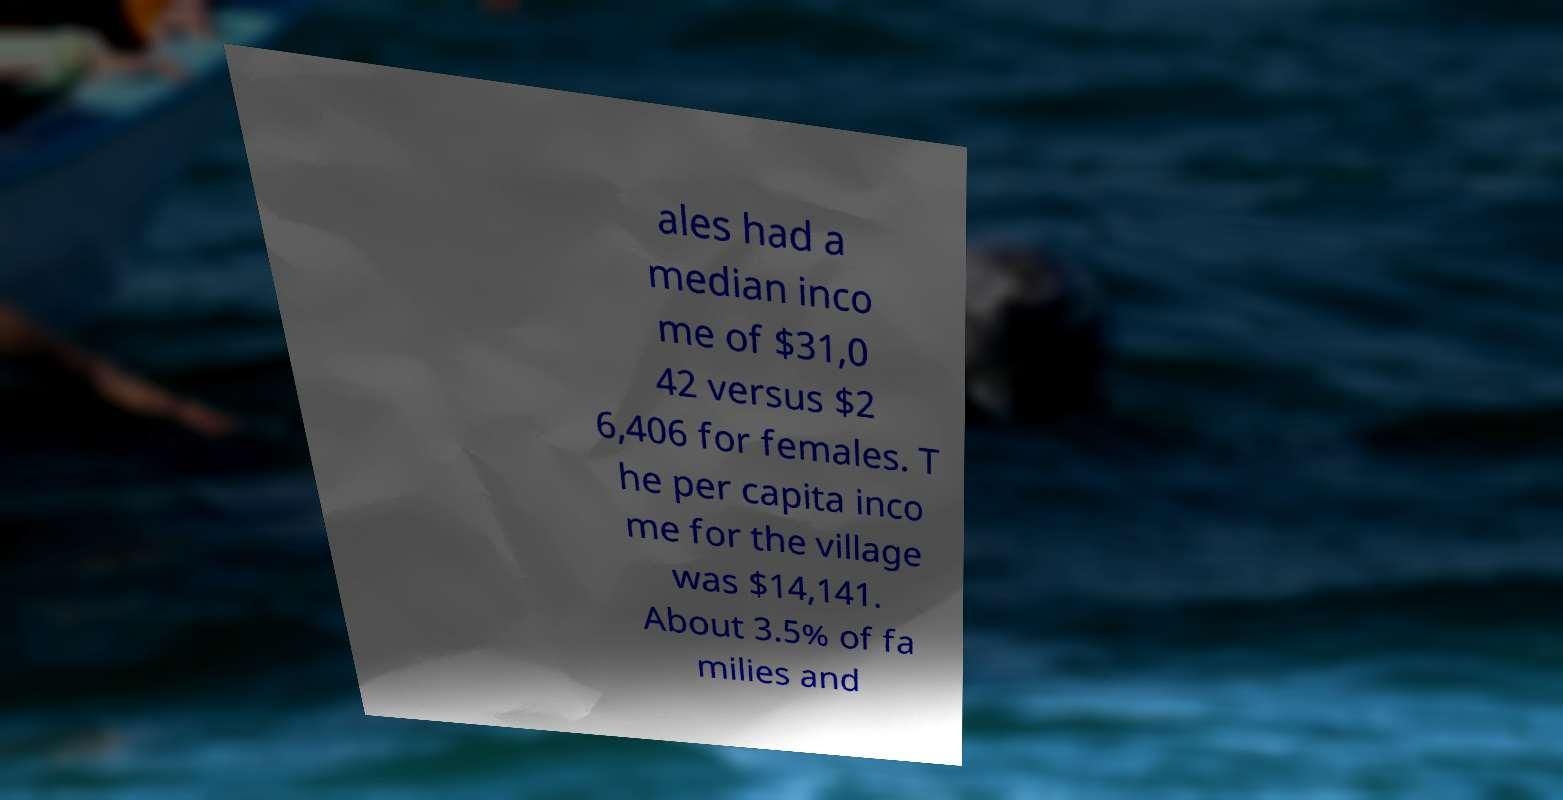For documentation purposes, I need the text within this image transcribed. Could you provide that? ales had a median inco me of $31,0 42 versus $2 6,406 for females. T he per capita inco me for the village was $14,141. About 3.5% of fa milies and 